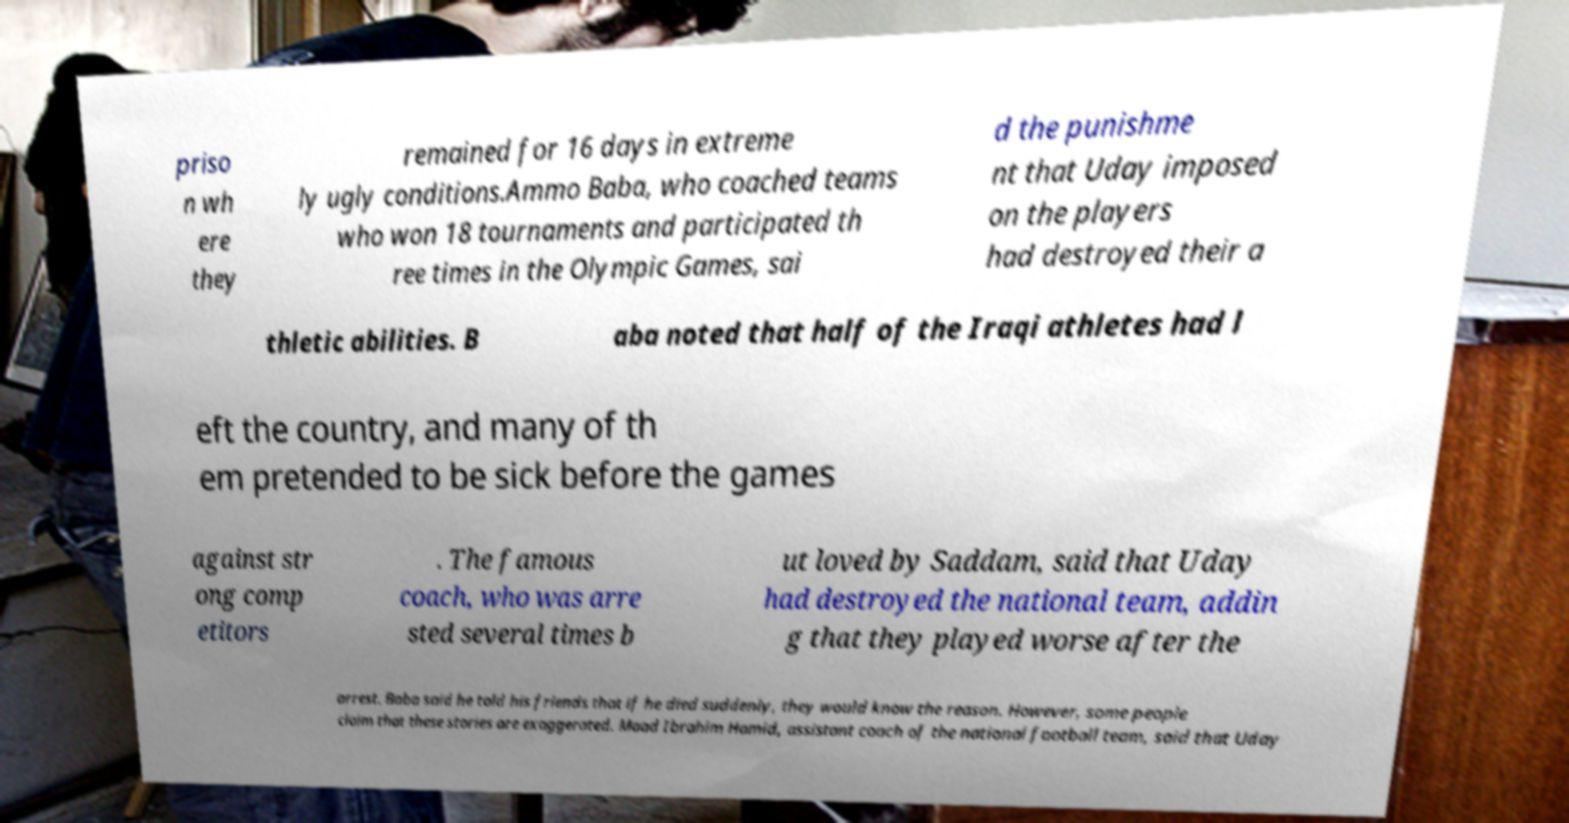What messages or text are displayed in this image? I need them in a readable, typed format. priso n wh ere they remained for 16 days in extreme ly ugly conditions.Ammo Baba, who coached teams who won 18 tournaments and participated th ree times in the Olympic Games, sai d the punishme nt that Uday imposed on the players had destroyed their a thletic abilities. B aba noted that half of the Iraqi athletes had l eft the country, and many of th em pretended to be sick before the games against str ong comp etitors . The famous coach, who was arre sted several times b ut loved by Saddam, said that Uday had destroyed the national team, addin g that they played worse after the arrest. Baba said he told his friends that if he died suddenly, they would know the reason. However, some people claim that these stories are exaggerated. Maad Ibrahim Hamid, assistant coach of the national football team, said that Uday 